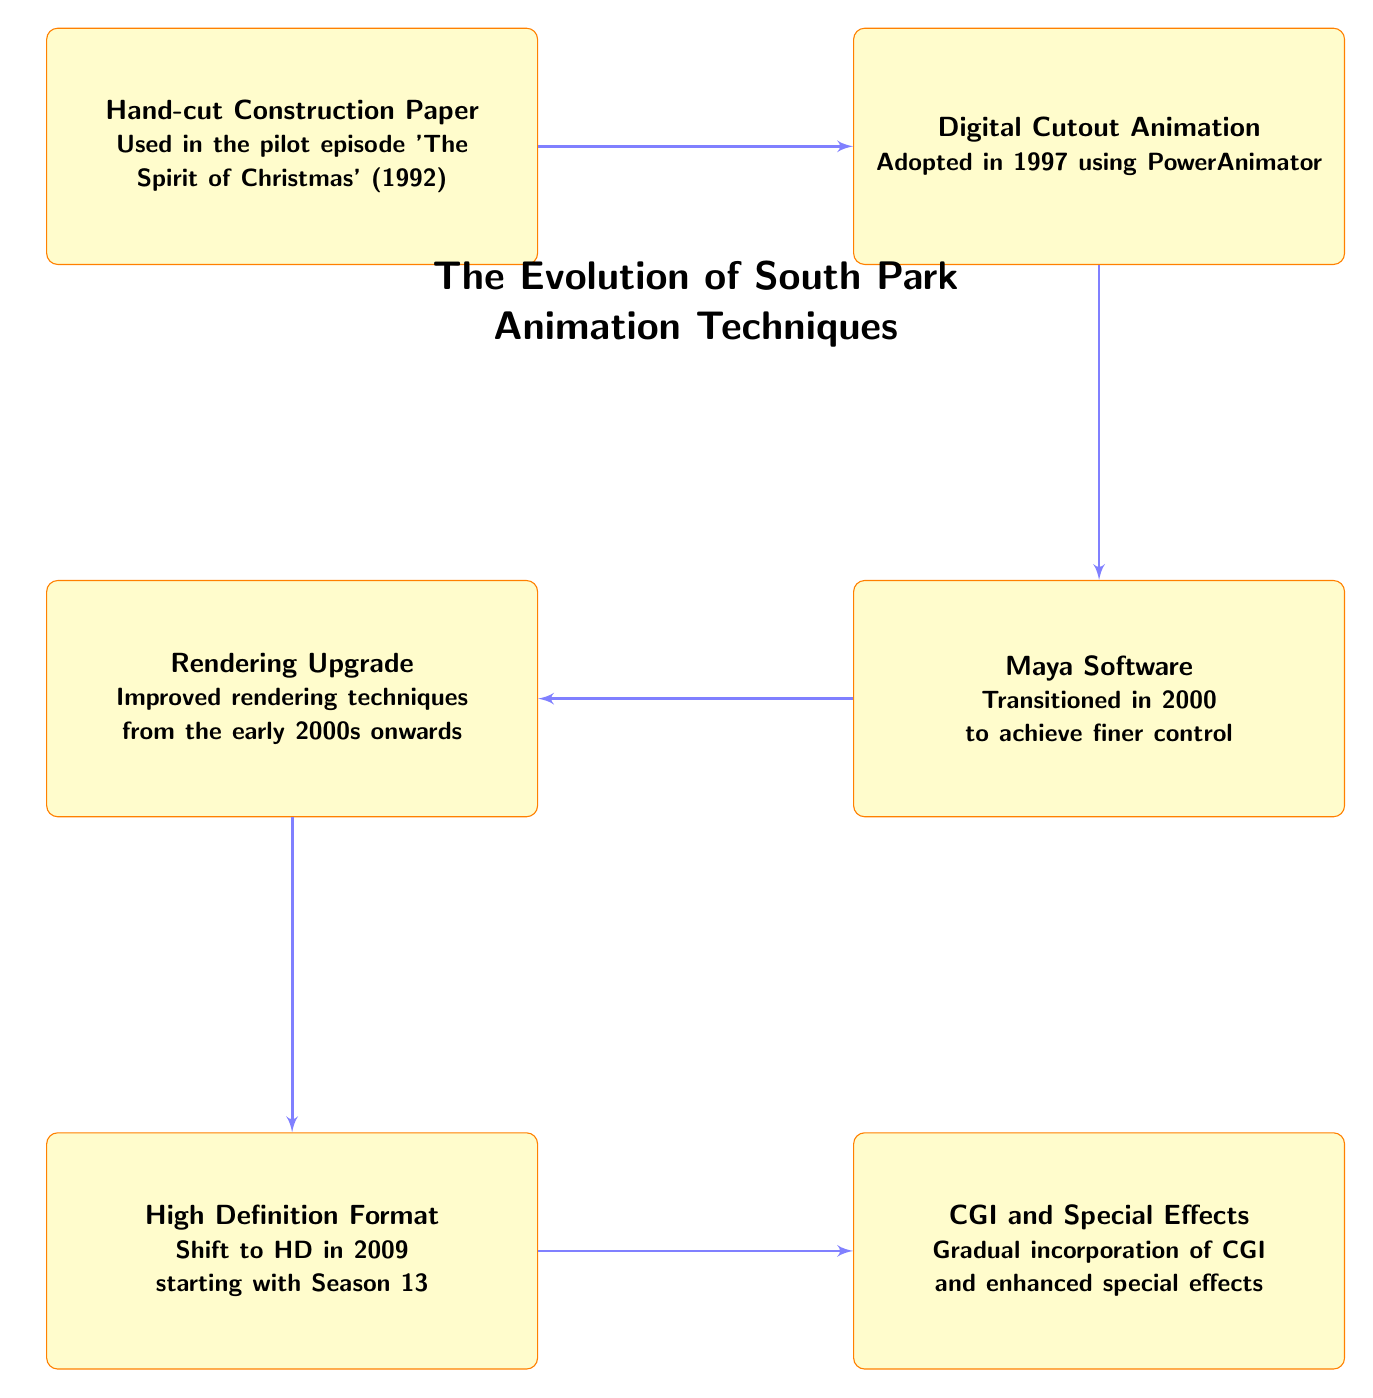What is the first animation technique used in South Park? The diagram shows that the first technique listed is "Hand-cut Construction Paper," which is mentioned in the first node.
Answer: Hand-cut Construction Paper What year did South Park transition to Digital Cutout Animation? By looking at the node for "Digital Cutout Animation," it states that this technique was adopted in 1997.
Answer: 1997 How many major animation techniques are depicted in this flowchart? The flowchart has a total of six nodes: Hand-cut Construction Paper, Digital Cutout Animation, Maya Software, Rendering Upgrade, High Definition Format, and CGI and Special Effects.
Answer: 6 What software was introduced for finer control in 2000? Referring to the node "Maya Software," it specifically mentions that this software was transitioned to in 2000 to achieve finer control.
Answer: Maya Software What is the final animation technique mentioned in the flowchart? The last node in the flowchart is "CGI and Special Effects," indicating it is the final technique represented.
Answer: CGI and Special Effects Explain the progression from Digital Cutout Animation to High Definition Format. The flowchart shows a sequence starting at "Digital Cutout Animation" in 1997, moving to "Maya Software" in 2000, then to "Rendering Upgrade" in the early 2000s, and finally to "High Definition Format," which began in 2009 with Season 13. Each step describes a transition to newer technology.
Answer: Digital Cutout Animation → Maya Software → Rendering Upgrade → High Definition Format In what year did South Park shift to High Definition Format? The node for "High Definition Format" indicates that this shift took place in 2009 when it began with Season 13.
Answer: 2009 